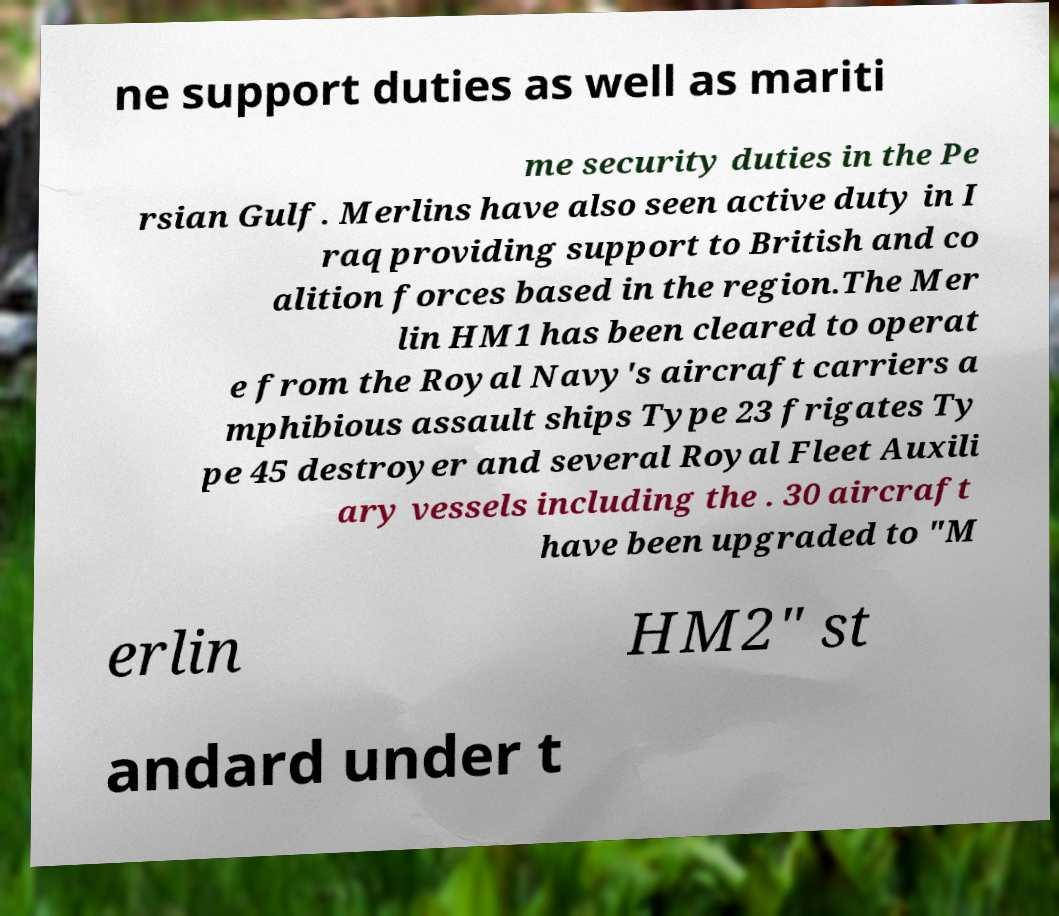Could you assist in decoding the text presented in this image and type it out clearly? ne support duties as well as mariti me security duties in the Pe rsian Gulf. Merlins have also seen active duty in I raq providing support to British and co alition forces based in the region.The Mer lin HM1 has been cleared to operat e from the Royal Navy's aircraft carriers a mphibious assault ships Type 23 frigates Ty pe 45 destroyer and several Royal Fleet Auxili ary vessels including the . 30 aircraft have been upgraded to "M erlin HM2" st andard under t 